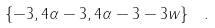<formula> <loc_0><loc_0><loc_500><loc_500>\left \{ - 3 , 4 \alpha - 3 , 4 \alpha - 3 - 3 w \right \} \ .</formula> 